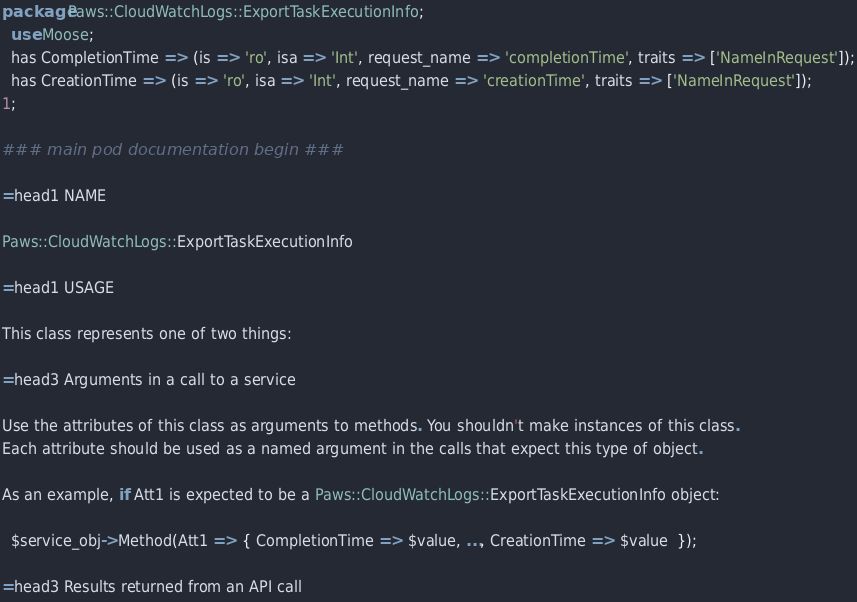Convert code to text. <code><loc_0><loc_0><loc_500><loc_500><_Perl_>package Paws::CloudWatchLogs::ExportTaskExecutionInfo;
  use Moose;
  has CompletionTime => (is => 'ro', isa => 'Int', request_name => 'completionTime', traits => ['NameInRequest']);
  has CreationTime => (is => 'ro', isa => 'Int', request_name => 'creationTime', traits => ['NameInRequest']);
1;

### main pod documentation begin ###

=head1 NAME

Paws::CloudWatchLogs::ExportTaskExecutionInfo

=head1 USAGE

This class represents one of two things:

=head3 Arguments in a call to a service

Use the attributes of this class as arguments to methods. You shouldn't make instances of this class. 
Each attribute should be used as a named argument in the calls that expect this type of object.

As an example, if Att1 is expected to be a Paws::CloudWatchLogs::ExportTaskExecutionInfo object:

  $service_obj->Method(Att1 => { CompletionTime => $value, ..., CreationTime => $value  });

=head3 Results returned from an API call
</code> 